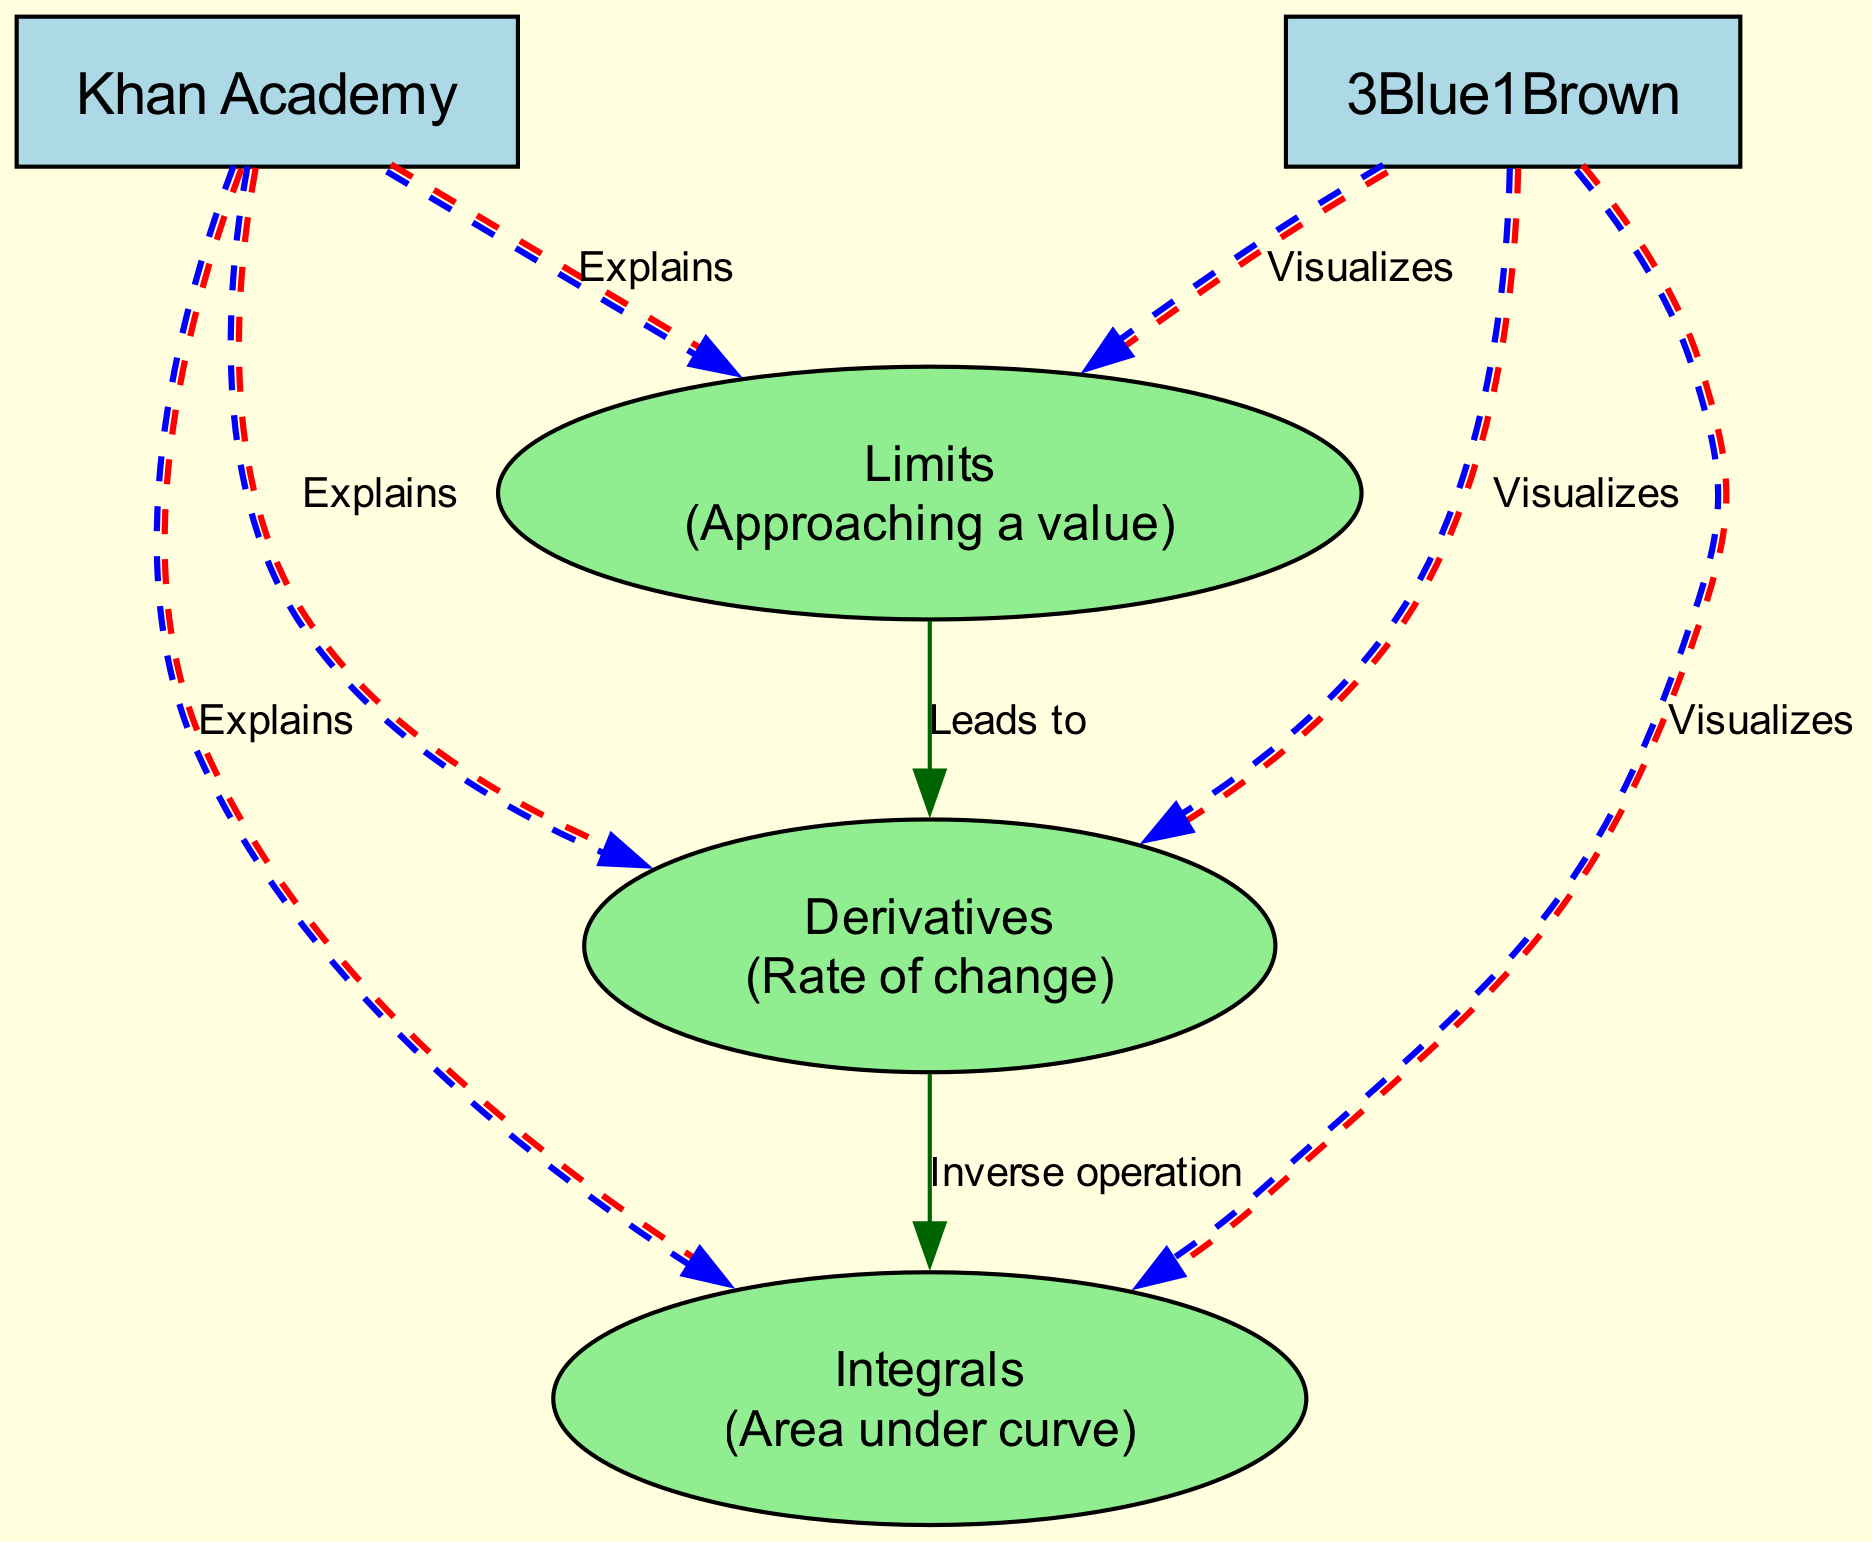What are the three main calculus concepts represented in the diagram? The diagram has three main nodes labeled "Limits", "Derivatives", and "Integrals". These represent the core concepts of calculus.
Answer: Limits, Derivatives, Integrals How many nodes are present in the diagram? The diagram contains five nodes: three calculus concepts and two educational platforms. Counting them gives a total of five.
Answer: Five Which node describes "Rate of change"? The node labeled "Derivatives" specifically describes the concept of "Rate of change". This information can be found directly in the node label.
Answer: Derivatives What relationship does "Limits" have with "Derivatives"? The relationship is labeled "Leads to", indicating that understanding limits is fundamental for moving on to derivatives in calculus.
Answer: Leads to Which educational platform explains all three concepts? The node labeled "Khan Academy" explains "Limits", "Derivatives", and "Integrals", as seen from the edges connecting it to each of the three concepts.
Answer: Khan Academy How does "3Blue1Brown" relate to "Integrals"? The edge labeled "Visualizes" connects the node "3Blue1Brown" to the node "Integrals", indicating that 3Blue1Brown visualizes the concept of integrals.
Answer: Visualizes How many explanations does "Khan Academy" provide? "Khan Academy" is shown to explain all three of the calculus concepts, which means it provides three explanations.
Answer: Three What is the inverse operation between "Derivatives" and "Integrals"? The edge between these two nodes is labeled "Inverse operation," indicating that derivatives and integrals are oppositely related operations in calculus.
Answer: Inverse operation Which node visualizes all three calculus concepts? The node labeled "3Blue1Brown" visualizes "Limits", "Derivatives", and "Integrals", as indicated by the edges connecting it to each of the three concepts.
Answer: 3Blue1Brown 